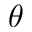Convert formula to latex. <formula><loc_0><loc_0><loc_500><loc_500>\theta</formula> 